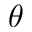Convert formula to latex. <formula><loc_0><loc_0><loc_500><loc_500>\theta</formula> 